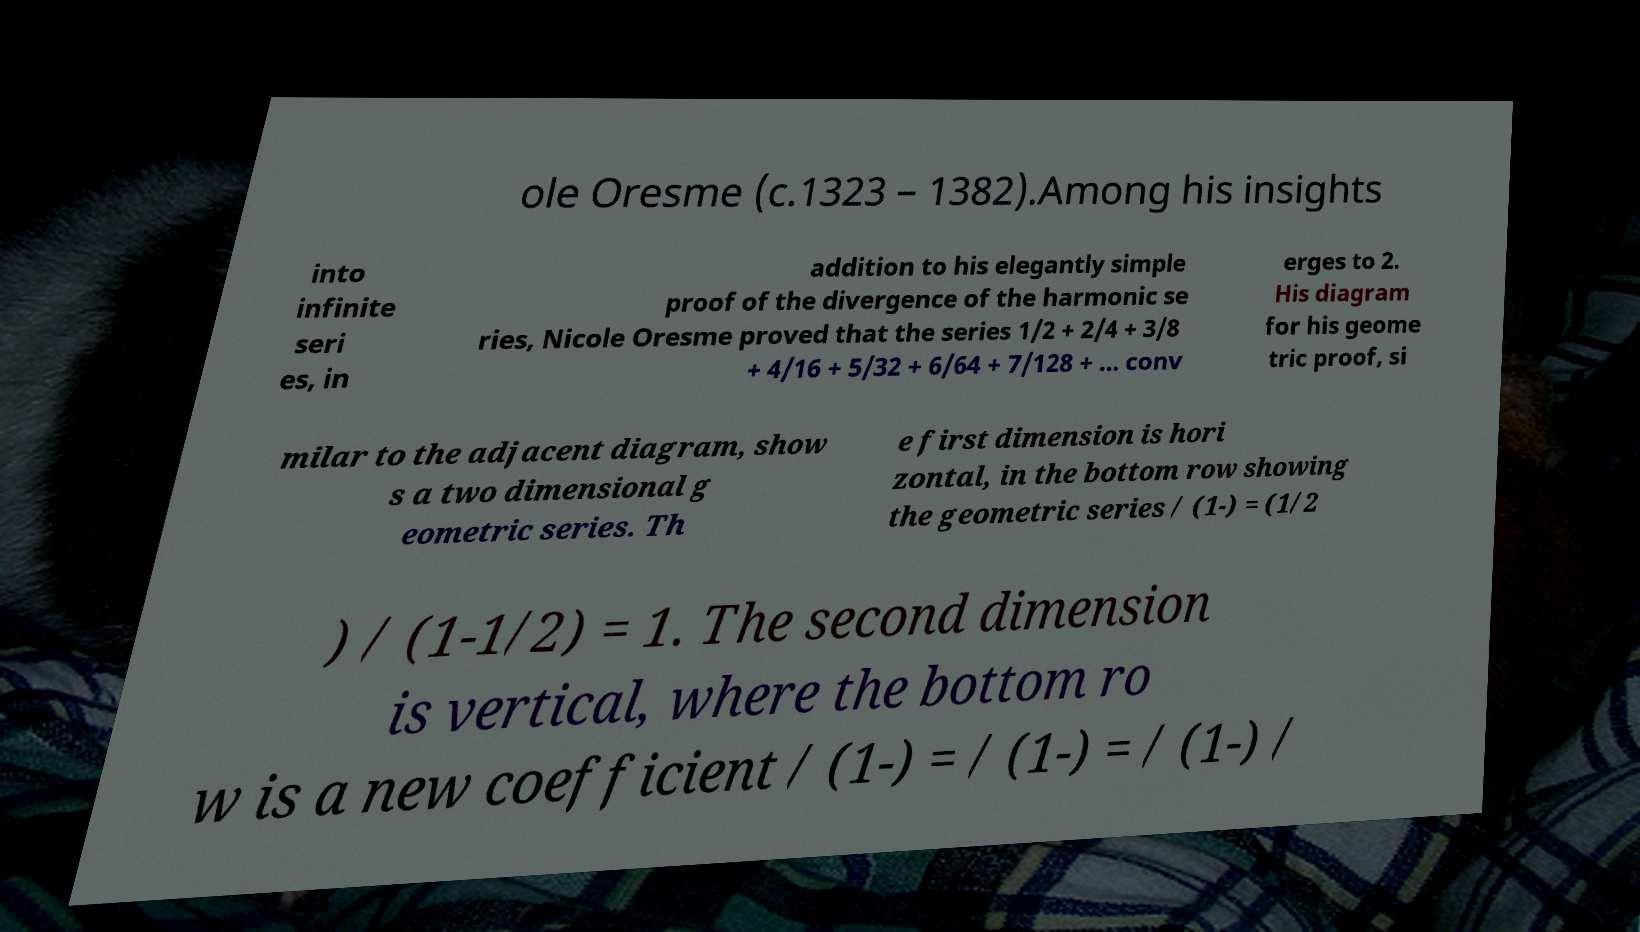There's text embedded in this image that I need extracted. Can you transcribe it verbatim? ole Oresme (c.1323 – 1382).Among his insights into infinite seri es, in addition to his elegantly simple proof of the divergence of the harmonic se ries, Nicole Oresme proved that the series 1/2 + 2/4 + 3/8 + 4/16 + 5/32 + 6/64 + 7/128 + ... conv erges to 2. His diagram for his geome tric proof, si milar to the adjacent diagram, show s a two dimensional g eometric series. Th e first dimension is hori zontal, in the bottom row showing the geometric series / (1-) = (1/2 ) / (1-1/2) = 1. The second dimension is vertical, where the bottom ro w is a new coefficient / (1-) = / (1-) = / (1-) / 